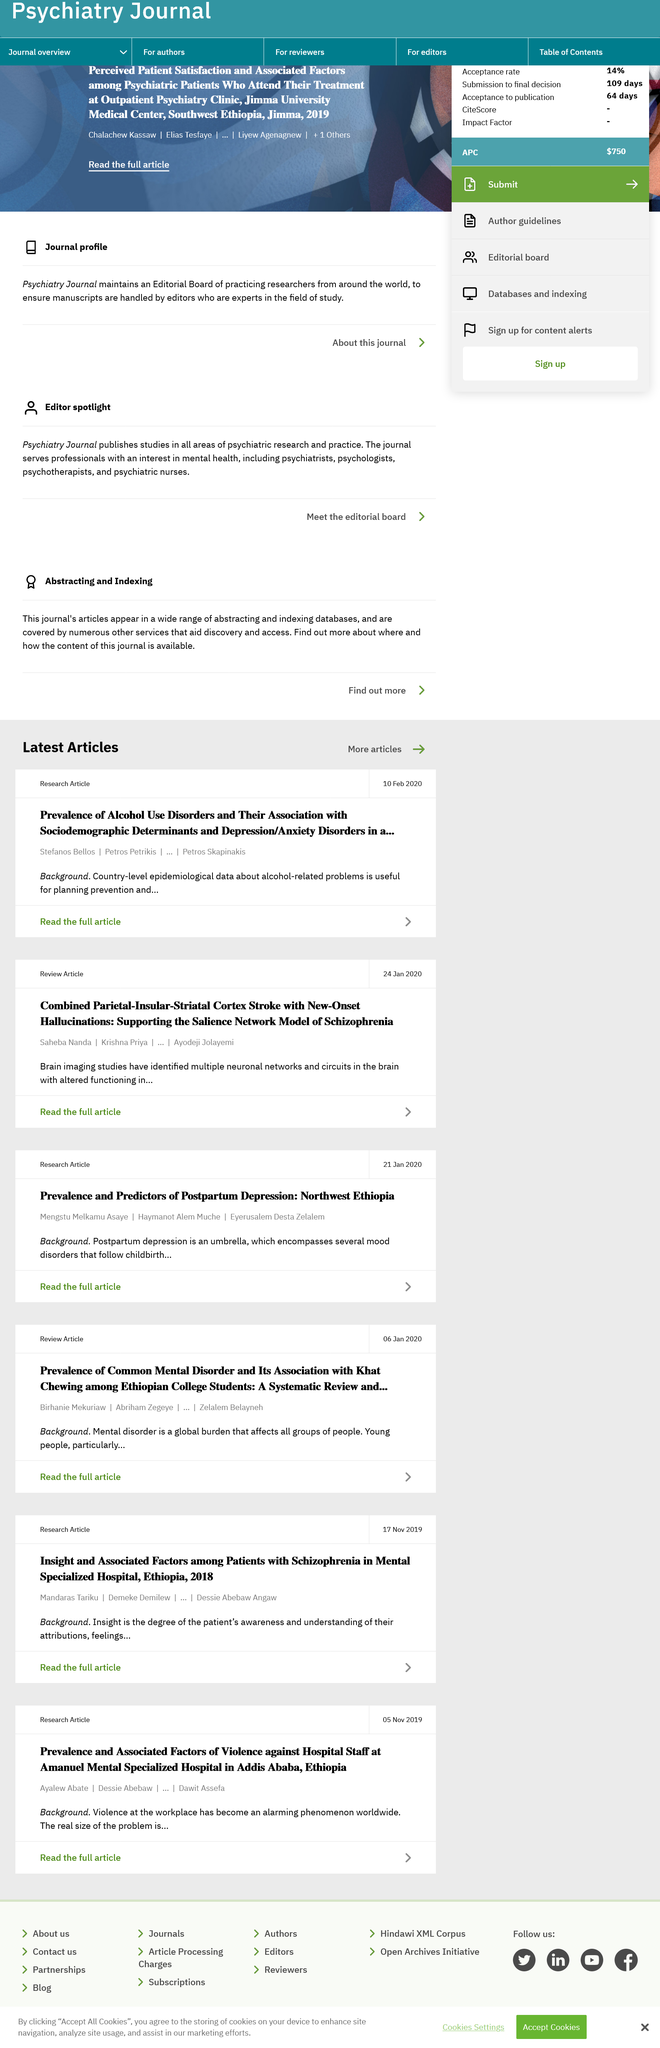Point out several critical features in this image. Abraham Zegeye is the second author of this paper. The increasing occurrence of violence at the workplace, both domestically and internationally, is a cause for concern and requires immediate attention and action. The Amanuel Mental Specialized Hospital is located in Addis Ababa, Ethiopia. There are three writers contributing to this article. Mental disorder is the disorder that is being studied. 